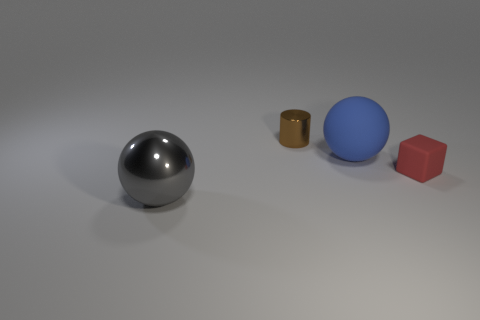Is there anything else that is the same material as the gray thing?
Your response must be concise. Yes. There is a blue object that is the same shape as the big gray thing; what is its size?
Provide a short and direct response. Large. Is the number of brown shiny objects behind the small shiny thing less than the number of tiny red blocks that are right of the small block?
Keep it short and to the point. No. What shape is the object that is both in front of the blue rubber ball and on the right side of the brown thing?
Keep it short and to the point. Cube. What is the size of the ball that is made of the same material as the red block?
Provide a succinct answer. Large. There is a rubber block; does it have the same color as the metallic object in front of the small metallic cylinder?
Your response must be concise. No. The object that is both to the right of the brown cylinder and behind the tiny red block is made of what material?
Keep it short and to the point. Rubber. There is a large object behind the large shiny ball; is it the same shape as the rubber thing in front of the large rubber thing?
Give a very brief answer. No. Is there a brown metallic thing?
Offer a very short reply. Yes. There is another object that is the same shape as the big gray shiny object; what color is it?
Offer a very short reply. Blue. 